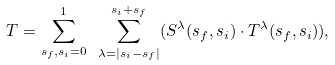<formula> <loc_0><loc_0><loc_500><loc_500>T = \sum _ { s _ { f } , s _ { i } = 0 } ^ { 1 } \ \sum _ { \lambda = | s _ { i } - s _ { f } | } ^ { s _ { i } + s _ { f } } ( S ^ { \lambda } ( s _ { f } , s _ { i } ) \cdot T ^ { \lambda } ( s _ { f } , s _ { i } ) ) ,</formula> 